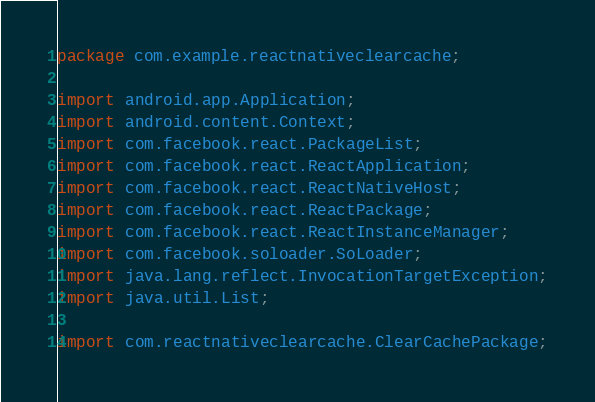<code> <loc_0><loc_0><loc_500><loc_500><_Java_>package com.example.reactnativeclearcache;

import android.app.Application;
import android.content.Context;
import com.facebook.react.PackageList;
import com.facebook.react.ReactApplication;
import com.facebook.react.ReactNativeHost;
import com.facebook.react.ReactPackage;
import com.facebook.react.ReactInstanceManager;
import com.facebook.soloader.SoLoader;
import java.lang.reflect.InvocationTargetException;
import java.util.List;

import com.reactnativeclearcache.ClearCachePackage;
</code> 